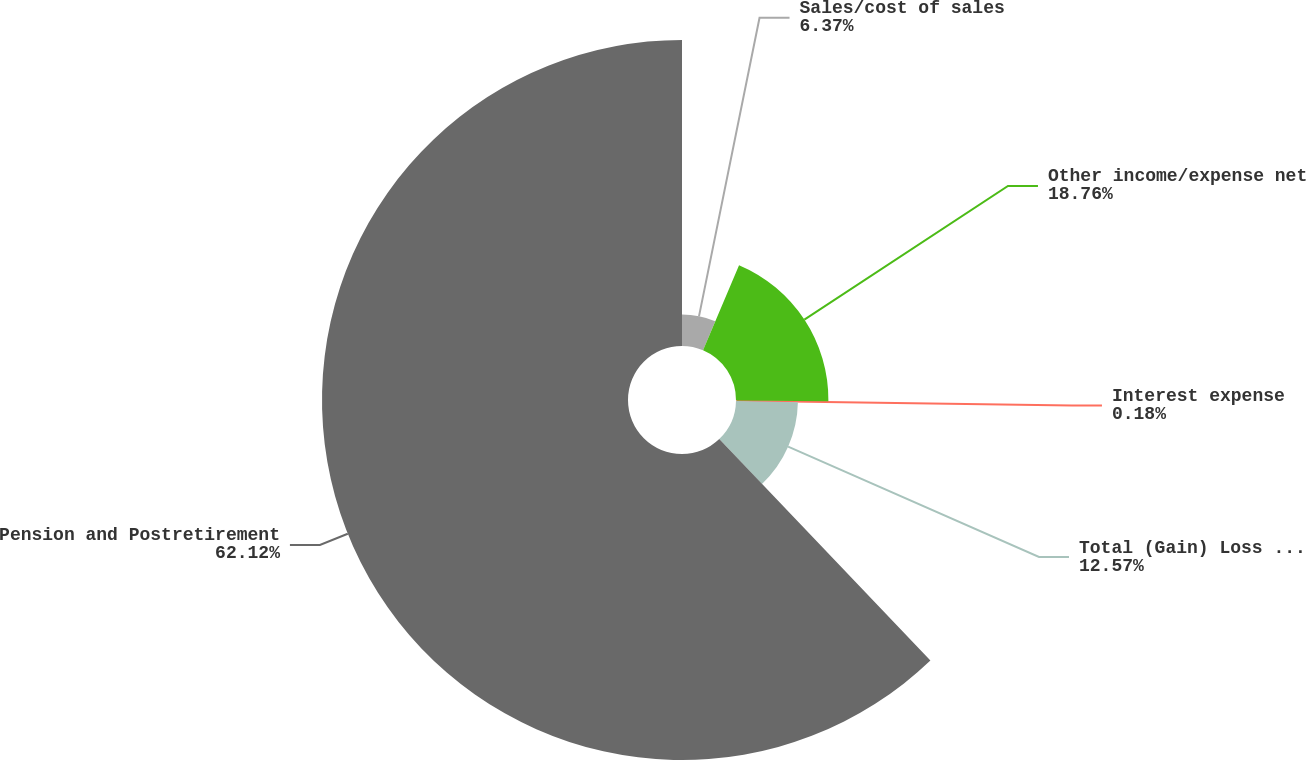<chart> <loc_0><loc_0><loc_500><loc_500><pie_chart><fcel>Sales/cost of sales<fcel>Other income/expense net<fcel>Interest expense<fcel>Total (Gain) Loss on Cash Flow<fcel>Pension and Postretirement<nl><fcel>6.37%<fcel>18.76%<fcel>0.18%<fcel>12.57%<fcel>62.12%<nl></chart> 